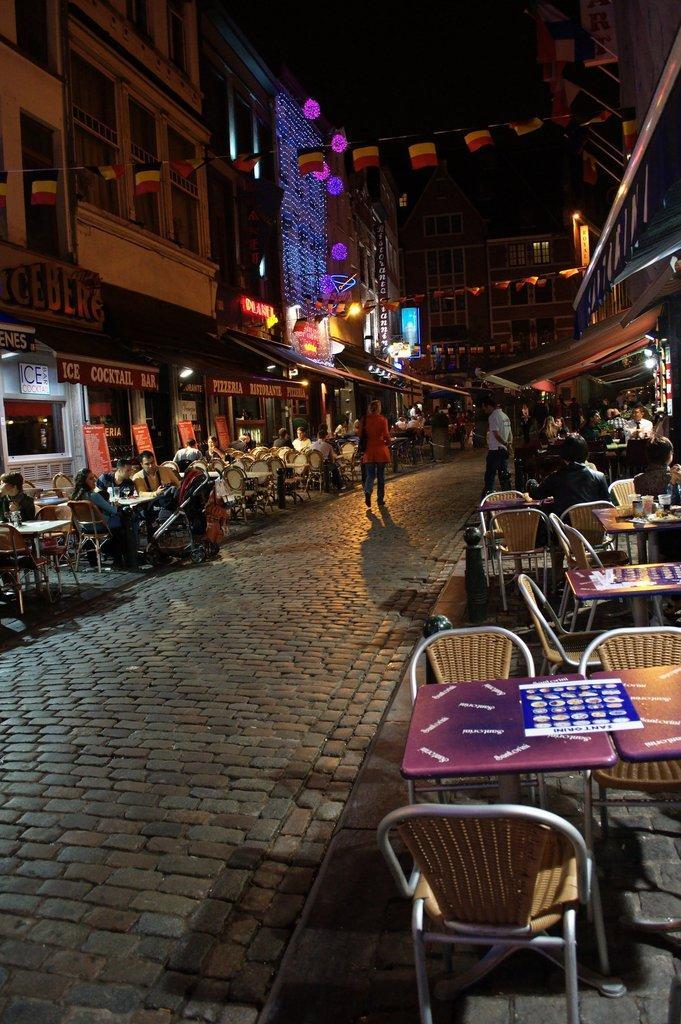Could you give a brief overview of what you see in this image? In the image we can see there are chairs and tables. People are sitting on chair and few people are standing on road and there are lot of buildings all around. 